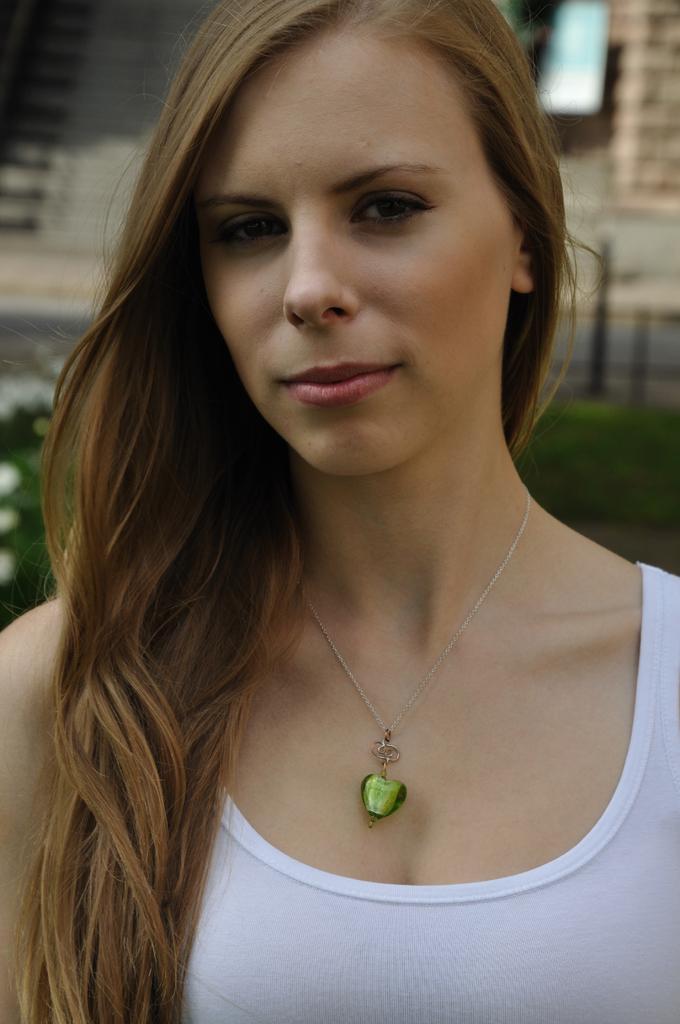Could you give a brief overview of what you see in this image? In this image we can see a woman is standing, she's smiling, she's wearing the locket. 